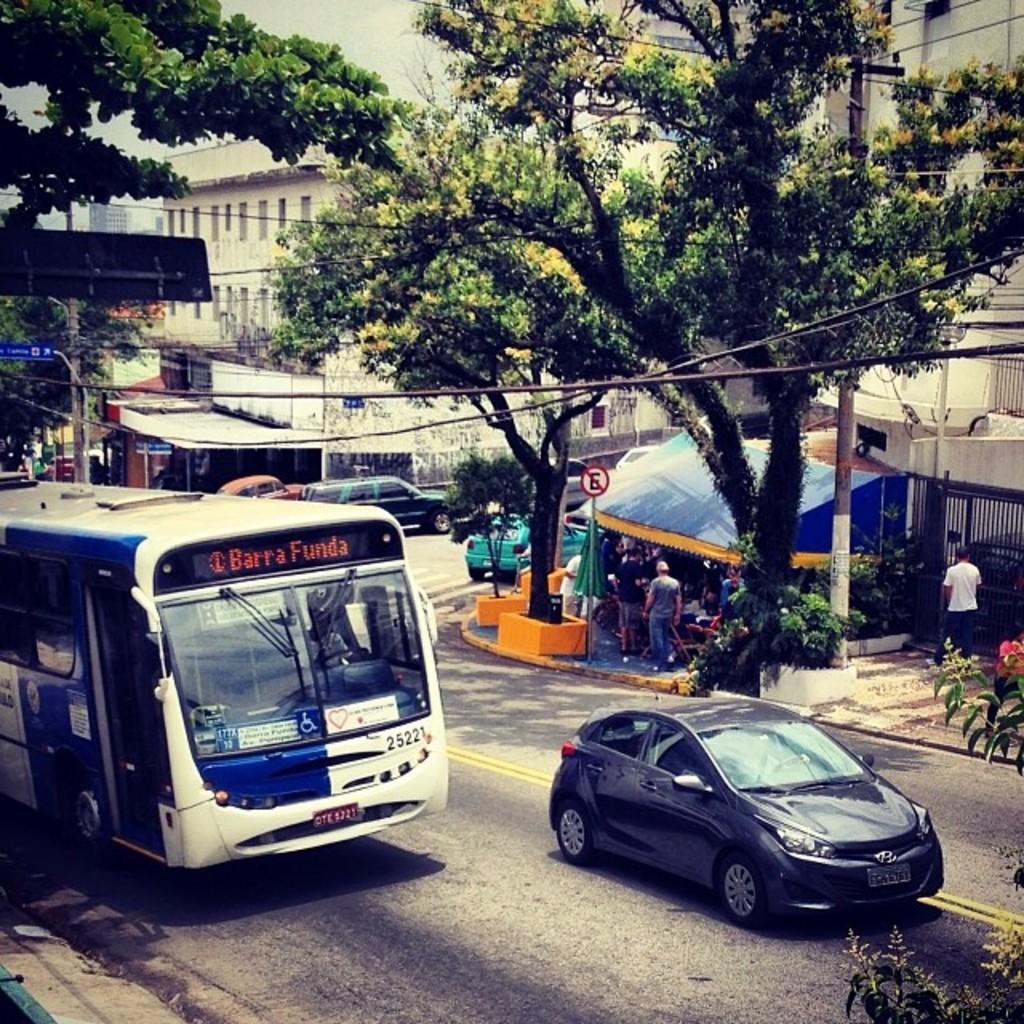Could you give a brief overview of what you see in this image? Vehicles are on the road. Here we can see trees, signboards, poles, people, buildings and tent. Beside this person there is a grill. 